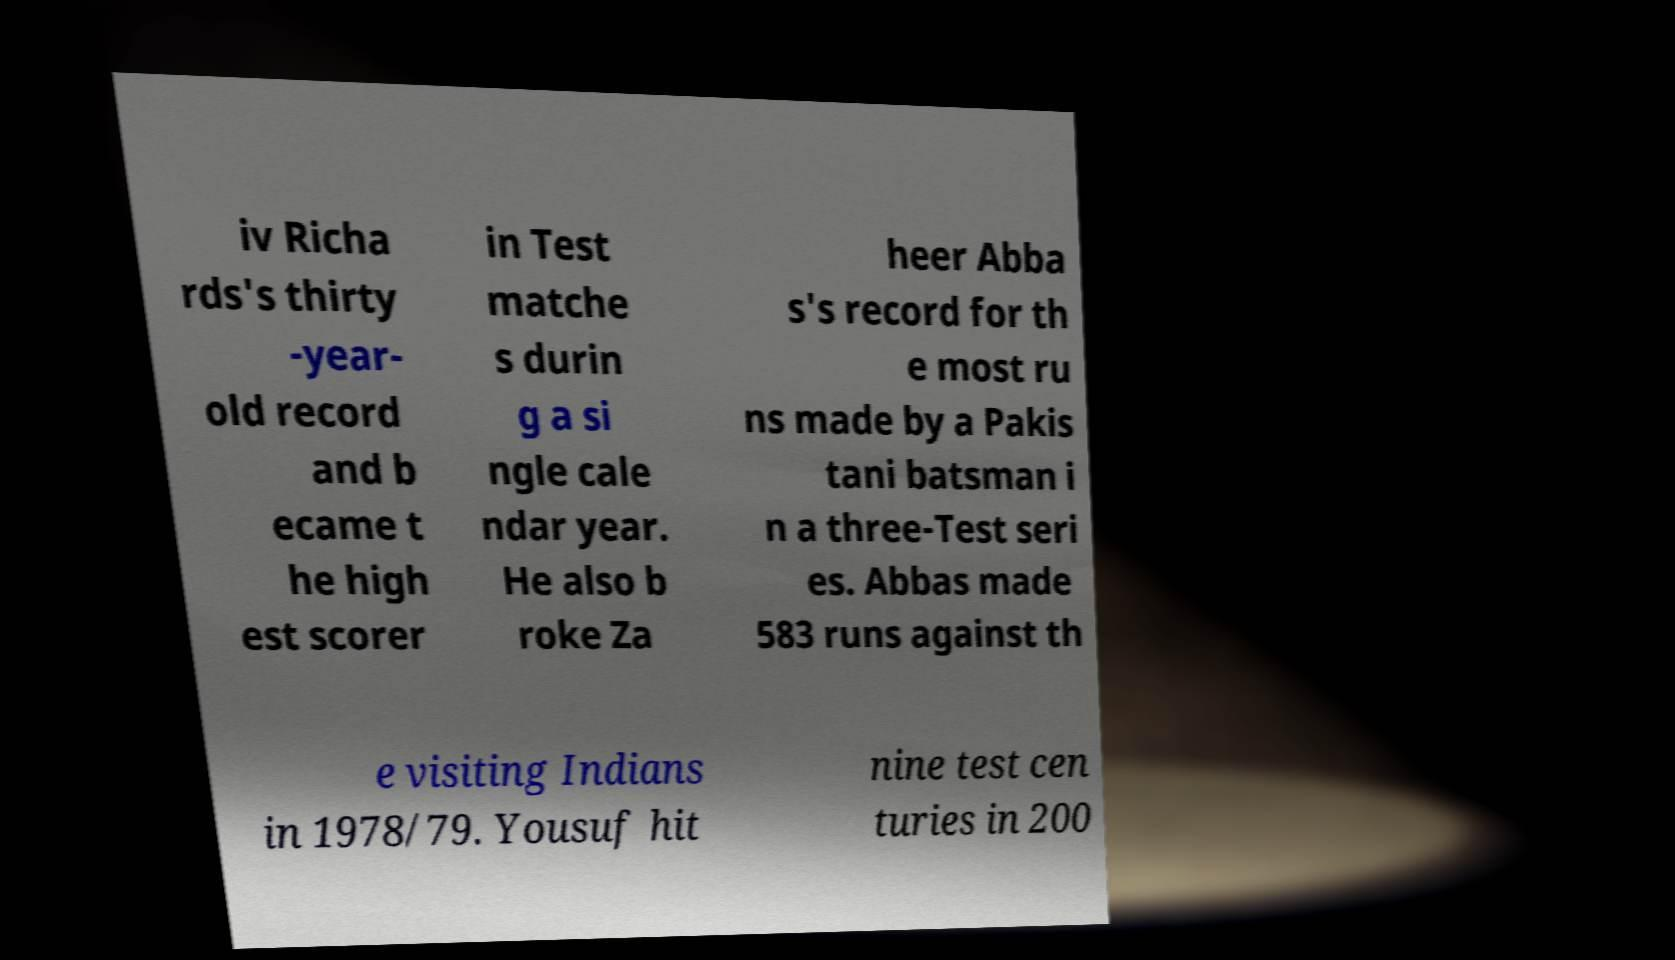Could you assist in decoding the text presented in this image and type it out clearly? iv Richa rds's thirty -year- old record and b ecame t he high est scorer in Test matche s durin g a si ngle cale ndar year. He also b roke Za heer Abba s's record for th e most ru ns made by a Pakis tani batsman i n a three-Test seri es. Abbas made 583 runs against th e visiting Indians in 1978/79. Yousuf hit nine test cen turies in 200 